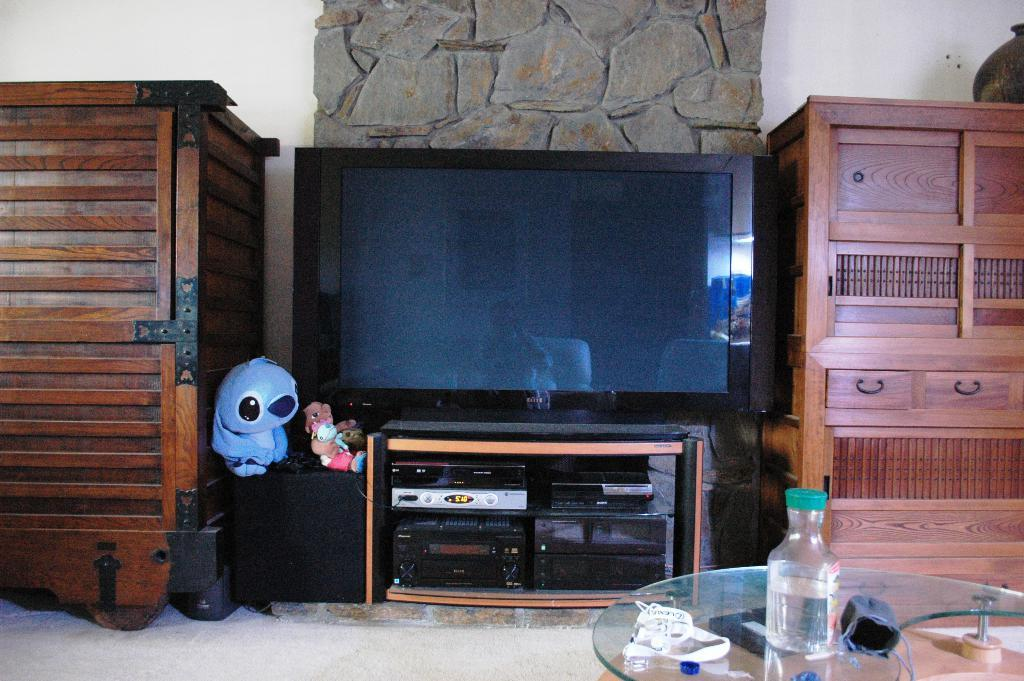What is the color of the wall in the image? The wall in the image is white. What type of object can be seen on the ground in the image? There is a rock in the image. What electronic device is present in the image? There is a television in the image. What piece of furniture is in the image? There is a table in the image. What is placed on the table in the image? There is a bottle on the table. How many locks are visible on the wall in the image? There are no locks visible on the wall in the image. What type of property is being sold in the image? There is no property being sold in the image; it only shows a wall, a rock, a television, a table, and a bottle. 